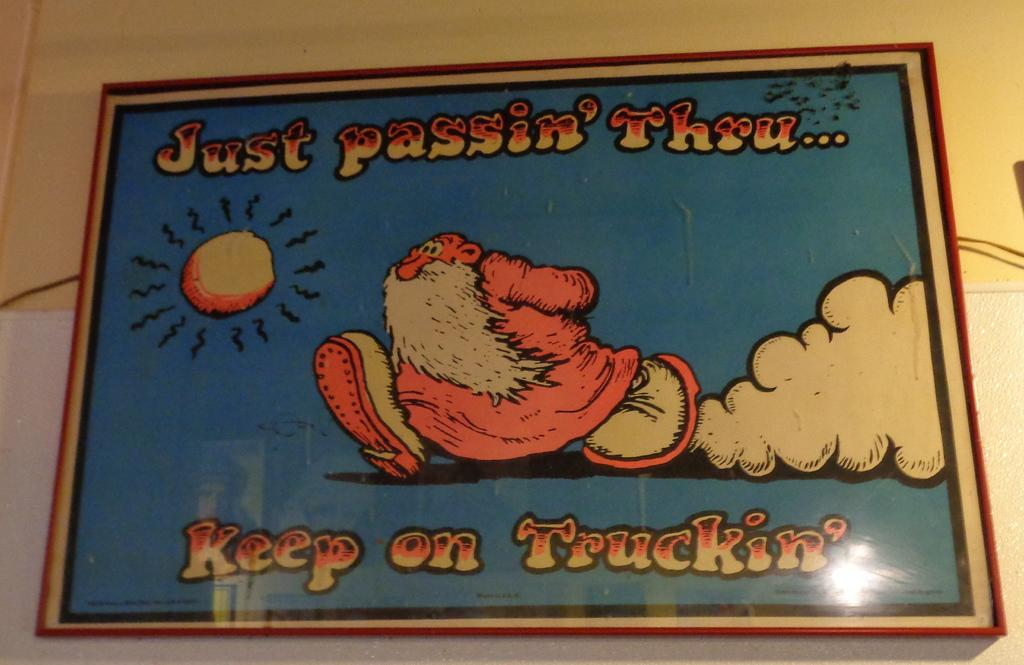<image>
Share a concise interpretation of the image provided. A sign that says Just passin' Thru... Keep on Truckin' 